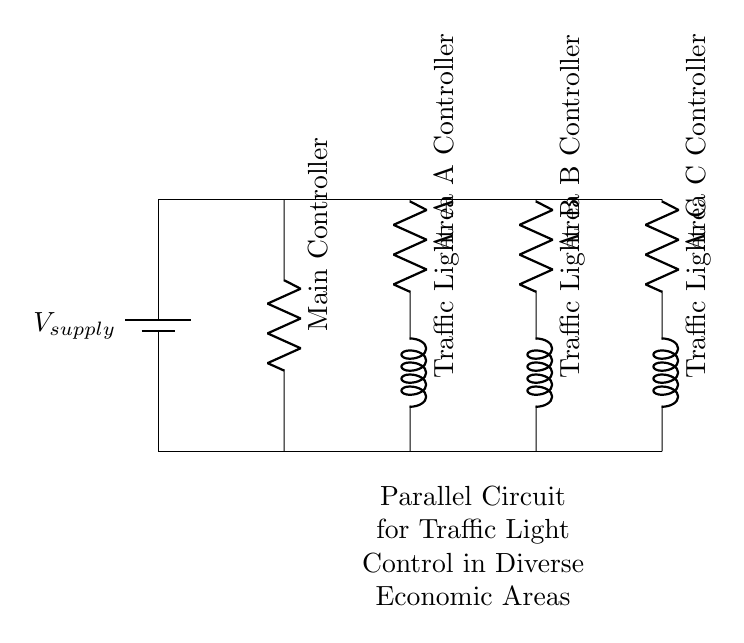What types of controllers are used in this circuit? The circuit shows three types of controllers: the Main Controller, Area A Controller, Area B Controller, and Area C Controller, which are all resistors in the diagram.
Answer: Main, Area A, Area B, Area C How many traffic lights are controlled in this circuit? There are three traffic lights represented in the circuit: Traffic Light A, Traffic Light B, and Traffic Light C, one for each area controller.
Answer: Three What is the configuration of this circuit? The circuit is structured in a parallel configuration, where multiple components operate independently from each other but are connected to the same voltage supply.
Answer: Parallel How does the voltage supply affect each traffic light? Since the circuit is parallel, each traffic light receives the full voltage from the supply independently, which means they do not affect each other's operation.
Answer: Full voltage What role does the Main Controller play in this circuit? The Main Controller regulates the overall traffic control system by managing the signals sent to the area-specific controllers, ensuring coordination among the traffic lights.
Answer: Coordination Why is a parallel circuit chosen for traffic light control? A parallel circuit allows for independent operation of traffic lights, meaning that failure or changes in one area do not impact the others, essential for maintaining traffic flow in diverse areas.
Answer: Independent operation 